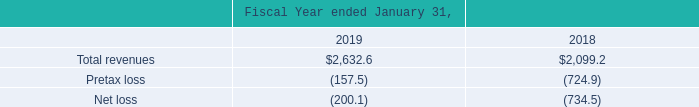Unaudited Pro Forma Results of Acquirees
Autodesk has included the financial results of each of the acquirees in the consolidated financial statements from the respective dates of acquisition; the revenues and the results of each of the acquirees, except for PlanGrid, have not been material both individually or in the aggregate to Autodesk's fiscal 2019 and 2018 results.
The following unaudited pro forma financial information summarizes the combined results of operations for Autodesk and PlanGrid, as though the companies were combined as of the beginning of Autodesk's fiscal year 2018. The unaudited pro forma financial information was as follows (in millions):
The pro forma financial information for all periods presented includes the business combination accounting effects from the acquisition of PlanGrid including amortization expense from acquired intangible assets, compensation expense, and the interest expense and debt issuance costs related to the term loan agreement. The historical financial information has been adjusted to give effect to pro forma events that are directly attributable to the business combinations and factually supportable. The pro forma financial information is for informational purposes only and is not indicative of the results of operations that would have been achieved if the acquisition had taken place at the beginning of the Company’s fiscal 2018.
The pro forma financial information for fiscal 2019 and 2018 combines the historical results of the Company, the adjusted historical results of PlanGrid for fiscal 2019 and 2018 considering the date the Company acquired PlanGrid and the effects of the pro forma adjustments described above
What does the pro forma financial information for all periods include? The pro forma financial information for all periods presented includes the business combination accounting effects from the acquisition of plangrid including amortization expense from acquired intangible assets, compensation expense, and the interest expense and debt issuance costs related to the term loan agreement. What does the pro forma financial information for fiscal 2019 and 2018 combine? The pro forma financial information for fiscal 2019 and 2018 combines the historical results of the company, the adjusted historical results of plangrid for fiscal 2019 and 2018 considering the date the company acquired plangrid and the effects of the pro forma adjustments described above. What is the total revenue for the fiscal year 2019? $2,632.6. What is the % change in the total revenue from 2018 to 2019?
Answer scale should be: percent. (($2,632.6-$2,099.2)/$2,099.2)
Answer: 25.41. What is the change in the net loss from 2018 to 2019?
Answer scale should be: million. (734.5)-(200.1)
Answer: -534.4. What is the average total revenue from 2018 to 2019?
Answer scale should be: million. (2,632.6+2,099.2)/2 
Answer: 2365.9. 